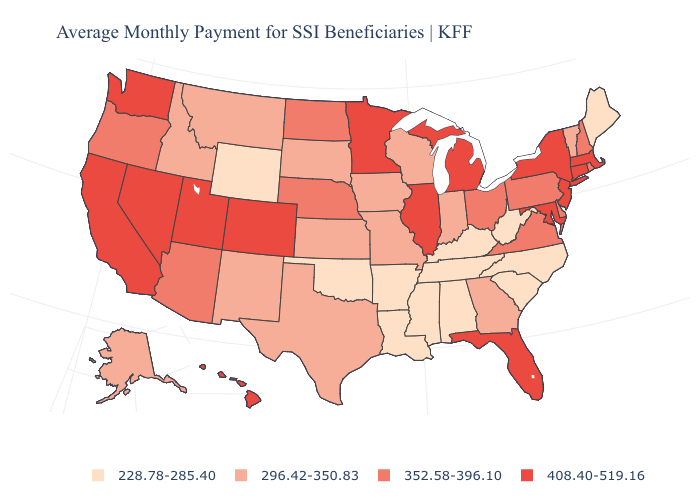Does Colorado have the highest value in the West?
Be succinct. Yes. Does Arizona have a higher value than Pennsylvania?
Concise answer only. No. Which states have the lowest value in the South?
Answer briefly. Alabama, Arkansas, Kentucky, Louisiana, Mississippi, North Carolina, Oklahoma, South Carolina, Tennessee, West Virginia. Which states have the lowest value in the Northeast?
Give a very brief answer. Maine. What is the value of Michigan?
Answer briefly. 408.40-519.16. Is the legend a continuous bar?
Concise answer only. No. What is the highest value in the USA?
Short answer required. 408.40-519.16. What is the value of Nevada?
Answer briefly. 408.40-519.16. Does Oregon have the highest value in the West?
Give a very brief answer. No. Name the states that have a value in the range 408.40-519.16?
Give a very brief answer. California, Colorado, Connecticut, Florida, Hawaii, Illinois, Maryland, Massachusetts, Michigan, Minnesota, Nevada, New Jersey, New York, Utah, Washington. Among the states that border Texas , does New Mexico have the highest value?
Answer briefly. Yes. What is the value of Iowa?
Concise answer only. 296.42-350.83. Does Massachusetts have the highest value in the Northeast?
Write a very short answer. Yes. What is the value of Hawaii?
Concise answer only. 408.40-519.16. What is the value of West Virginia?
Answer briefly. 228.78-285.40. 